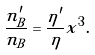<formula> <loc_0><loc_0><loc_500><loc_500>\frac { n ^ { \prime } _ { B } } { n _ { B } } = \frac { \eta ^ { \prime } } { \eta } x ^ { 3 } .</formula> 